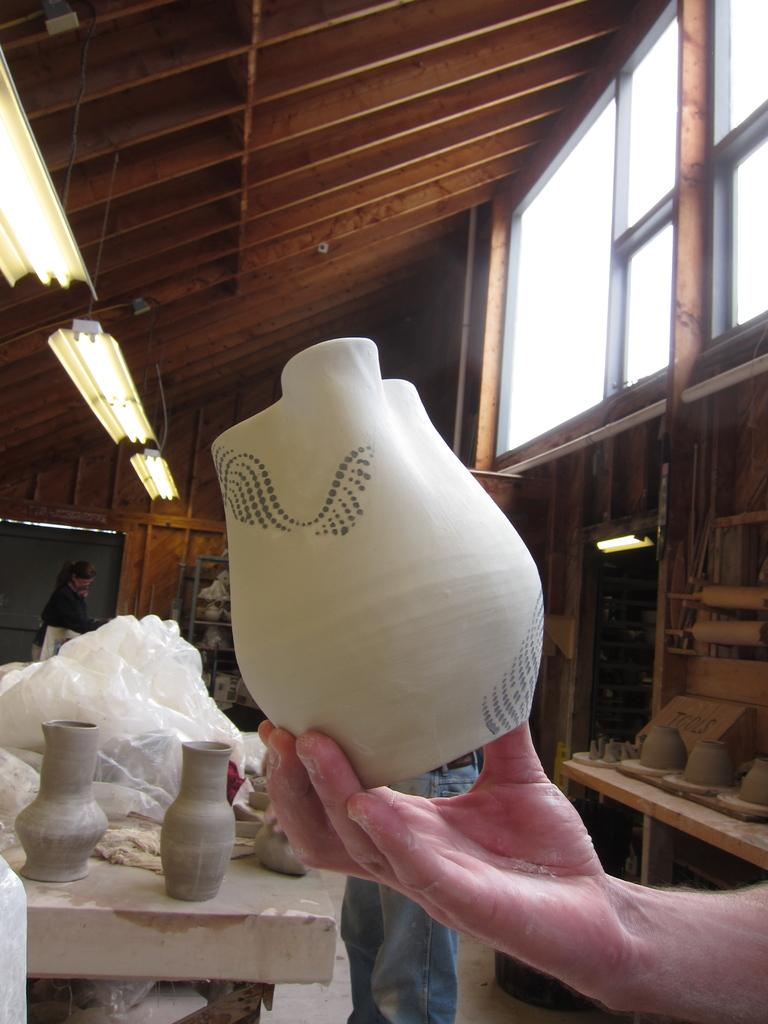What is the person in the image holding? The person is holding a white-colored pot in the image. What can be seen in the background of the image? Multiple pots, plastic objects, tube lights, and people are visible in the background. How many pots are visible in the background? There are multiple pots visible in the background, but the exact number is not specified. What type of vessel is the person embarking on in the image? There is no vessel or voyage depicted in the image; it only shows a person holding a pot and the background. 